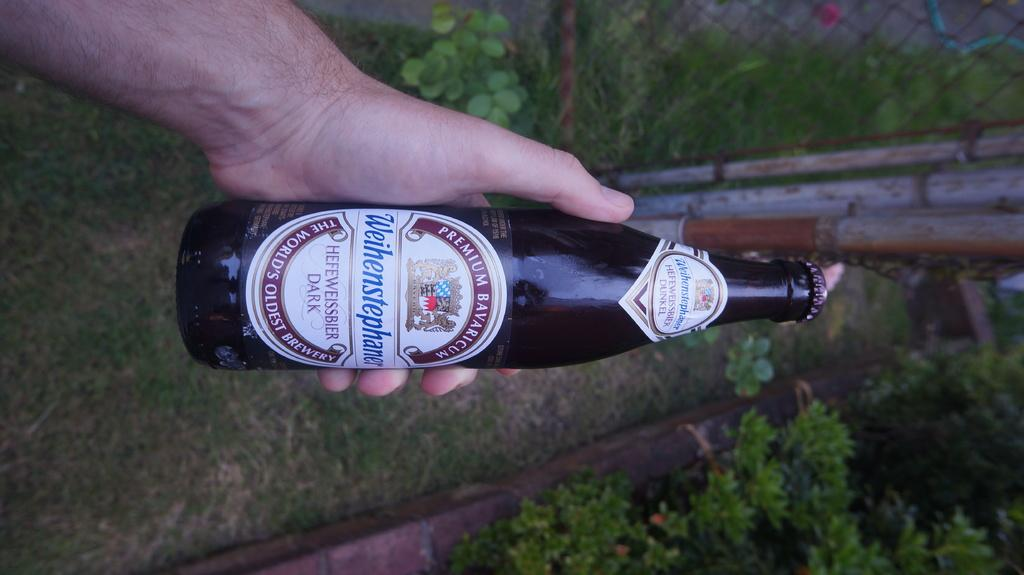Provide a one-sentence caption for the provided image. a bottle of liquor entitled PREMIUM BAVARICUM Weihenstphaner HEFEWEISSBIER DARK THE WORLD'S OLDEST BREWARY. 